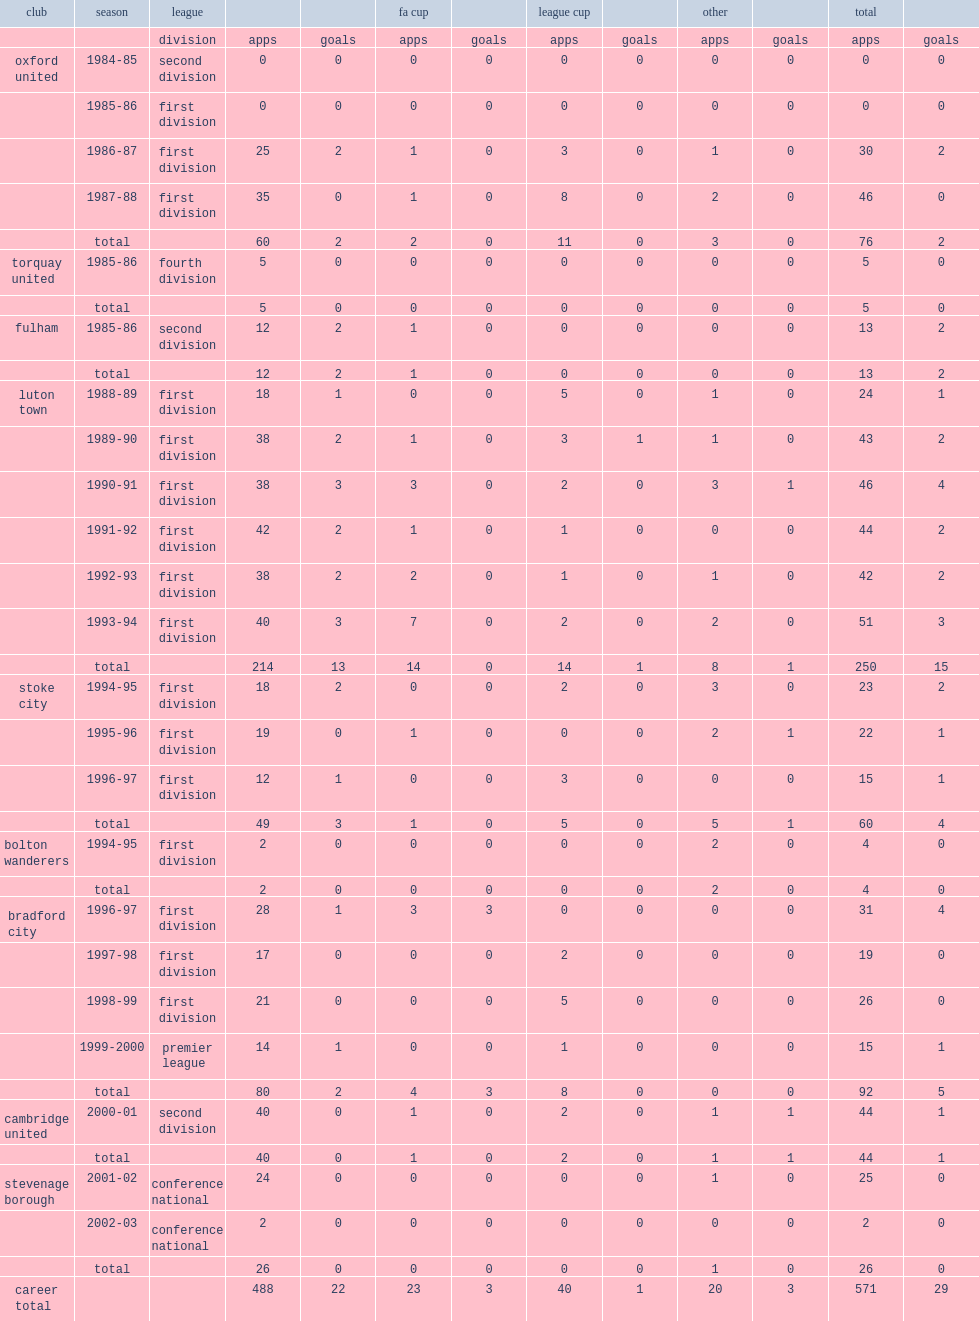In six years, how many games did john dreyer play at the end of the 1993-94 season? 214.0. In six years, how many times did john dreyer score at the end of the 1993-94 season? 13.0. 